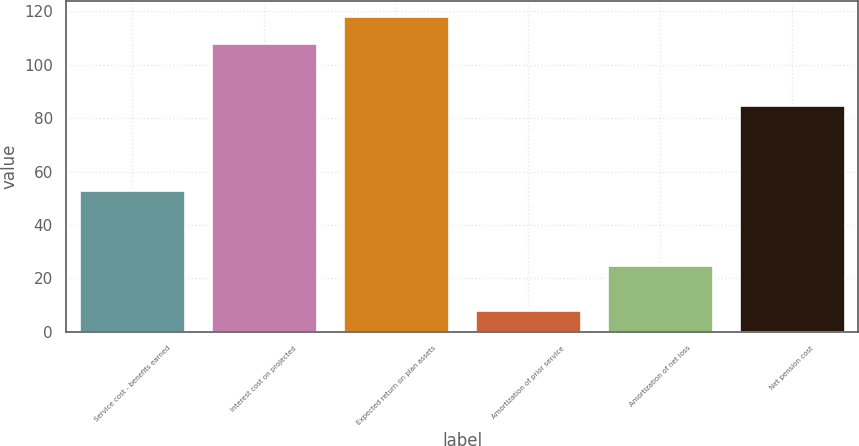Convert chart. <chart><loc_0><loc_0><loc_500><loc_500><bar_chart><fcel>Service cost - benefits earned<fcel>Interest cost on projected<fcel>Expected return on plan assets<fcel>Amortization of prior service<fcel>Amortization of net loss<fcel>Net pension cost<nl><fcel>53<fcel>108<fcel>118.1<fcel>8<fcel>25<fcel>85<nl></chart> 